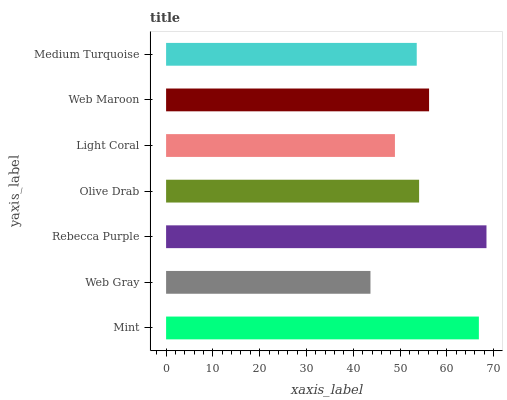Is Web Gray the minimum?
Answer yes or no. Yes. Is Rebecca Purple the maximum?
Answer yes or no. Yes. Is Rebecca Purple the minimum?
Answer yes or no. No. Is Web Gray the maximum?
Answer yes or no. No. Is Rebecca Purple greater than Web Gray?
Answer yes or no. Yes. Is Web Gray less than Rebecca Purple?
Answer yes or no. Yes. Is Web Gray greater than Rebecca Purple?
Answer yes or no. No. Is Rebecca Purple less than Web Gray?
Answer yes or no. No. Is Olive Drab the high median?
Answer yes or no. Yes. Is Olive Drab the low median?
Answer yes or no. Yes. Is Web Gray the high median?
Answer yes or no. No. Is Mint the low median?
Answer yes or no. No. 